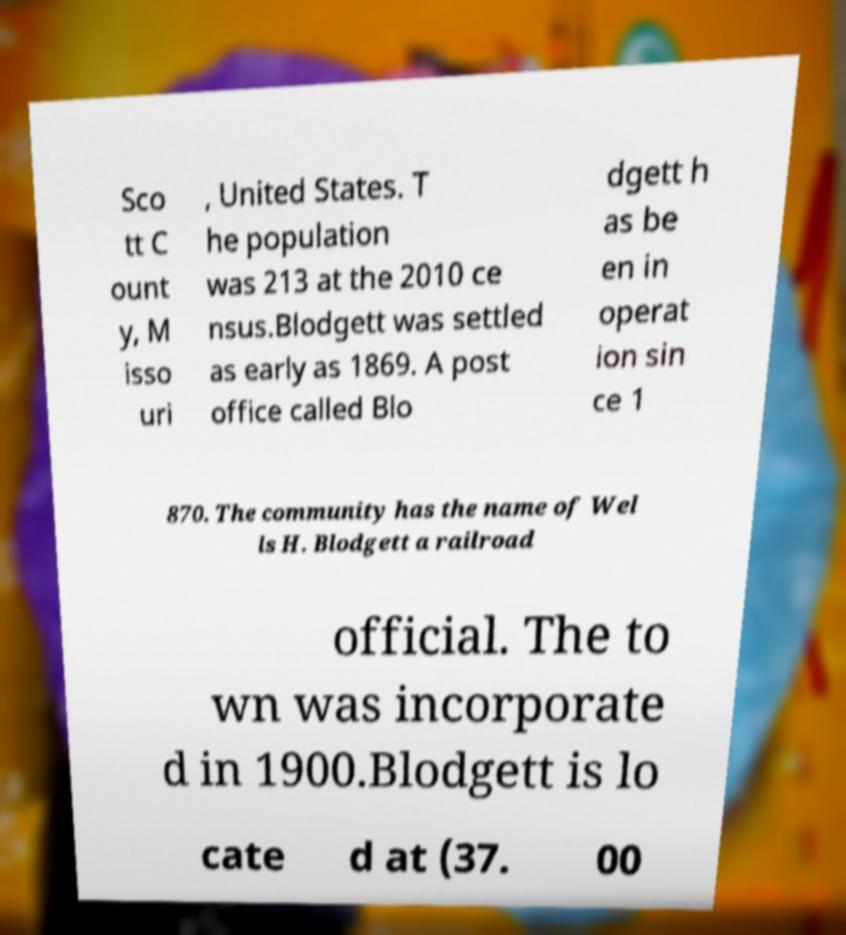I need the written content from this picture converted into text. Can you do that? Sco tt C ount y, M isso uri , United States. T he population was 213 at the 2010 ce nsus.Blodgett was settled as early as 1869. A post office called Blo dgett h as be en in operat ion sin ce 1 870. The community has the name of Wel ls H. Blodgett a railroad official. The to wn was incorporate d in 1900.Blodgett is lo cate d at (37. 00 